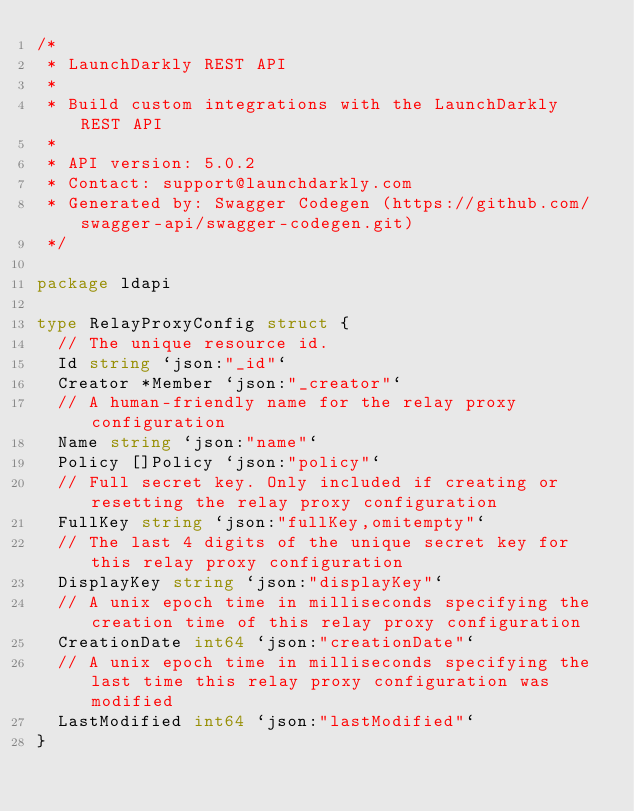<code> <loc_0><loc_0><loc_500><loc_500><_Go_>/*
 * LaunchDarkly REST API
 *
 * Build custom integrations with the LaunchDarkly REST API
 *
 * API version: 5.0.2
 * Contact: support@launchdarkly.com
 * Generated by: Swagger Codegen (https://github.com/swagger-api/swagger-codegen.git)
 */

package ldapi

type RelayProxyConfig struct {
	// The unique resource id.
	Id string `json:"_id"`
	Creator *Member `json:"_creator"`
	// A human-friendly name for the relay proxy configuration
	Name string `json:"name"`
	Policy []Policy `json:"policy"`
	// Full secret key. Only included if creating or resetting the relay proxy configuration
	FullKey string `json:"fullKey,omitempty"`
	// The last 4 digits of the unique secret key for this relay proxy configuration
	DisplayKey string `json:"displayKey"`
	// A unix epoch time in milliseconds specifying the creation time of this relay proxy configuration
	CreationDate int64 `json:"creationDate"`
	// A unix epoch time in milliseconds specifying the last time this relay proxy configuration was modified
	LastModified int64 `json:"lastModified"`
}
</code> 